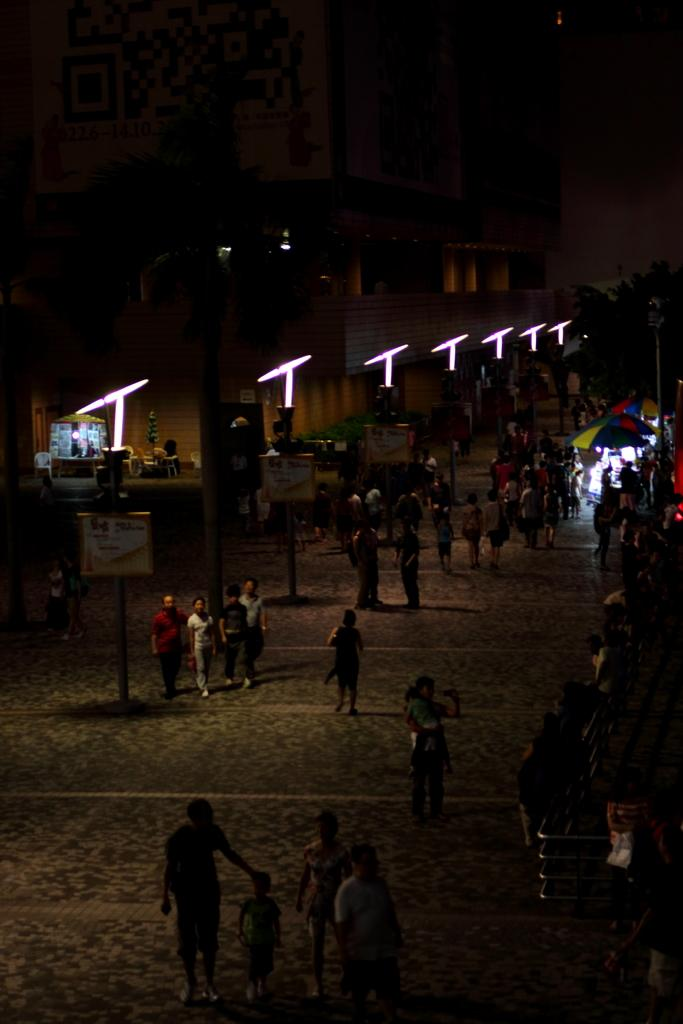What are the people in the image doing? The people in the image are walking. On what surface are the people walking? The people are walking on a pavement. What can be seen in the background of the image? There are buildings and lights visible in the background of the image. What type of pet is sitting on the roof in the image? There is no pet or roof present in the image; it features people walking on a pavement with buildings and lights in the background. 